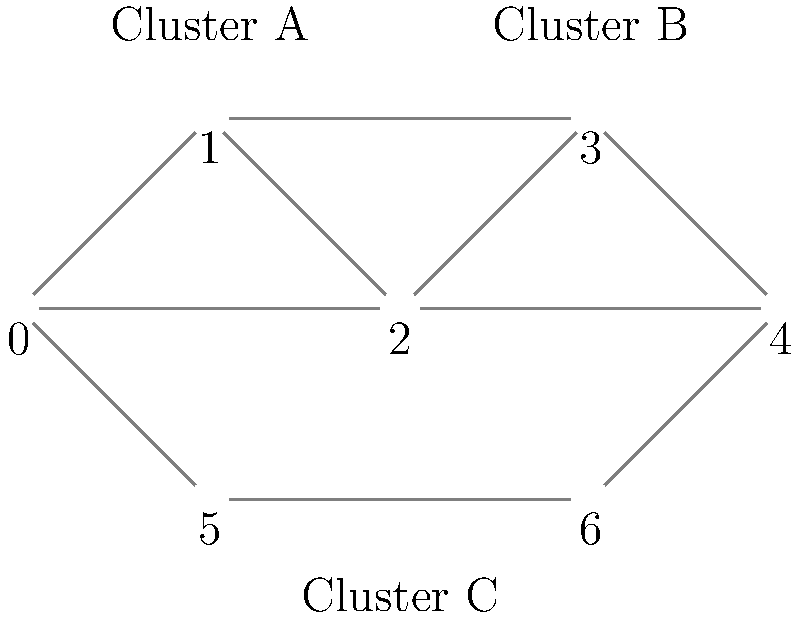In the graph representing symptom relationships for mental health disorders, how many distinct clusters can be identified, and which vertices belong to each cluster? To identify clusters in this graph, we need to analyze the connectivity and grouping of vertices:

1. First, we observe that there are 7 vertices (labeled 0 to 6) representing different symptoms.

2. We can identify three distinct clusters based on the connectivity:

   Cluster A: Vertices 0, 1, and 2 form a tightly connected group.
   - These vertices are all directly connected to each other.

   Cluster B: Vertices 3 and 4 form another group.
   - These vertices are connected to each other and also have connections to Cluster A.

   Cluster C: Vertices 5 and 6 form a separate group.
   - These vertices are connected to each other and have limited connections to the other clusters (only through vertices 0 and 4).

3. The clusters are identified based on:
   - Higher internal connectivity within the cluster
   - Fewer connections between clusters

4. Cluster A and B have more interconnections, which might suggest related symptom groups, while Cluster C is more isolated, potentially representing a distinct symptom group.

5. In the context of mental health disorders, these clusters could represent:
   - Cluster A: Core symptoms of a primary disorder
   - Cluster B: Related or secondary symptoms
   - Cluster C: Symptoms of a comorbid condition

Therefore, we can identify 3 distinct clusters in this graph.
Answer: 3 clusters: A(0,1,2), B(3,4), C(5,6) 